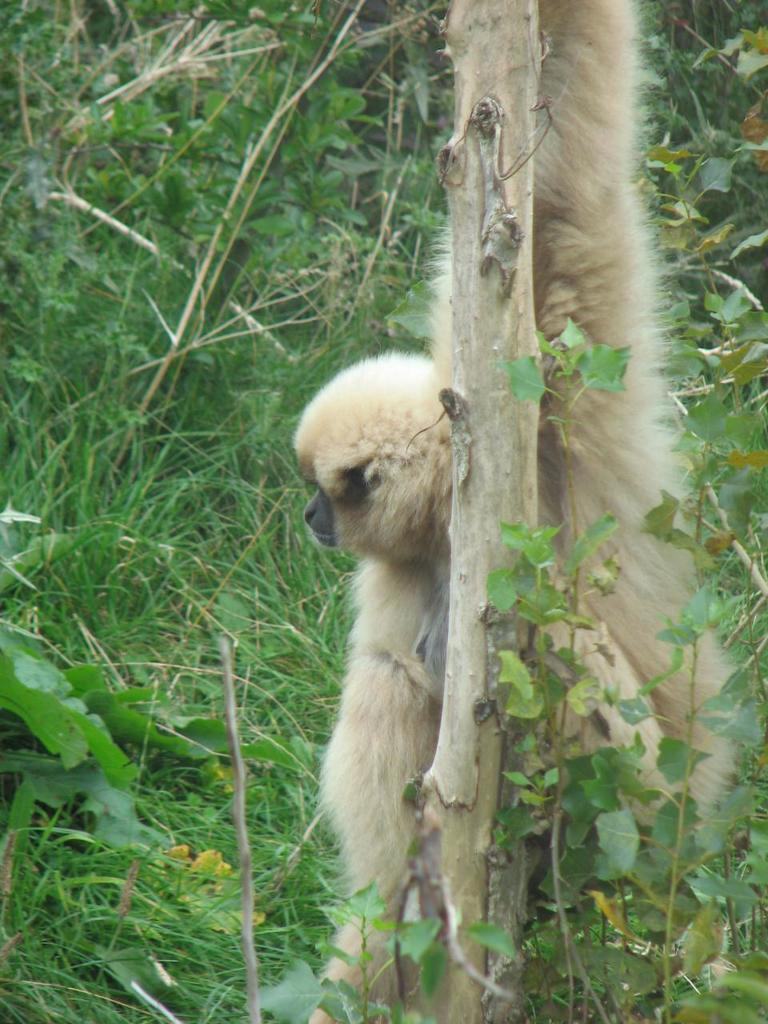What animal is present in the image? There is a monkey in the picture. What is the monkey holding in the image? The monkey is holding a tree in the image. What type of vegetation can be seen in the image? There is grass and plants in the picture. What type of zipper can be seen on the monkey's clothing in the image? There is no clothing or zipper present on the monkey in the image. 